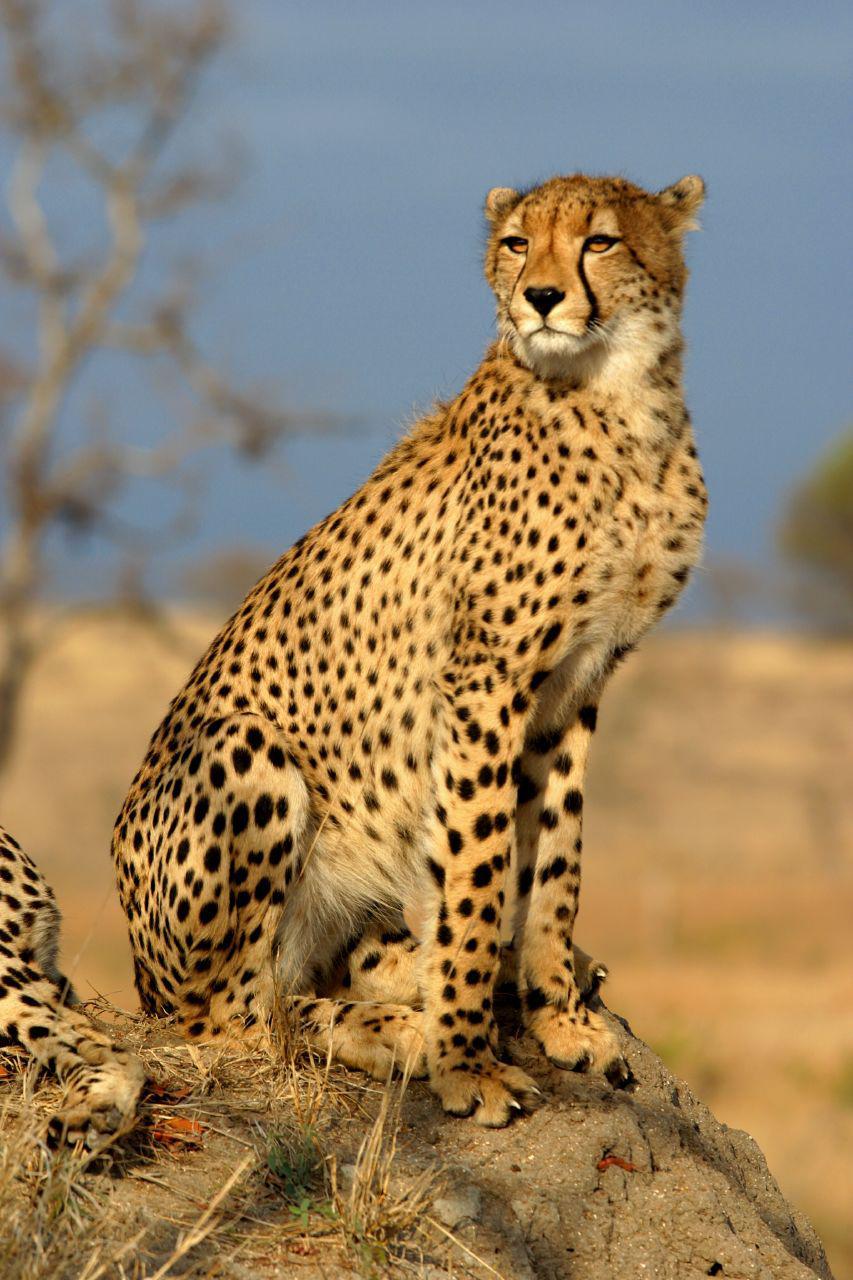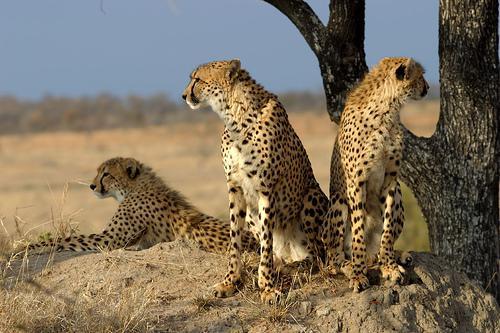The first image is the image on the left, the second image is the image on the right. For the images shown, is this caption "Right image shows three cheetahs looking in a variety of directions." true? Answer yes or no. Yes. The first image is the image on the left, the second image is the image on the right. For the images shown, is this caption "The image on the right has no more than three cheetahs." true? Answer yes or no. Yes. 